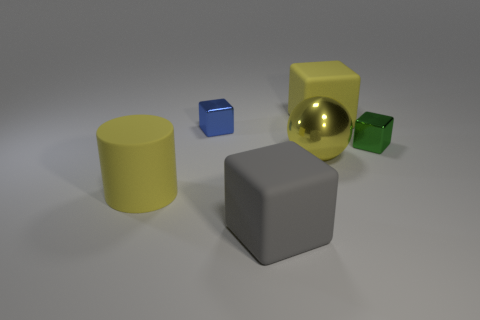How big is the rubber cylinder?
Your answer should be compact. Large. There is a block that is both in front of the tiny blue shiny block and to the right of the gray matte block; what size is it?
Give a very brief answer. Small. What shape is the green metal thing that is right of the large cube that is on the right side of the large yellow metallic ball?
Keep it short and to the point. Cube. The yellow rubber object to the right of the blue metallic object has what shape?
Give a very brief answer. Cube. What shape is the rubber thing that is in front of the tiny green shiny block and behind the large gray object?
Offer a terse response. Cylinder. How many red things are either metallic spheres or rubber blocks?
Offer a very short reply. 0. There is a big matte block behind the large yellow metal thing; does it have the same color as the large cylinder?
Offer a terse response. Yes. There is a yellow rubber object left of the large yellow object behind the green metallic thing; how big is it?
Provide a short and direct response. Large. What material is the blue cube that is the same size as the green shiny thing?
Provide a short and direct response. Metal. What number of other things are the same size as the blue metallic object?
Offer a terse response. 1. 